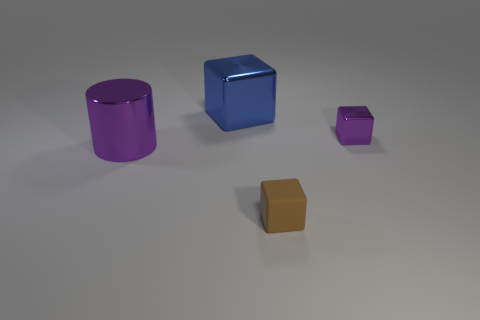Is there any other thing that has the same material as the tiny brown thing?
Your answer should be compact. No. Is the number of purple cylinders that are right of the cylinder the same as the number of blue blocks to the right of the rubber cube?
Provide a short and direct response. Yes. Is there a purple rubber cylinder?
Make the answer very short. No. What size is the matte object that is the same shape as the large blue shiny thing?
Provide a short and direct response. Small. There is a purple metal thing to the right of the brown rubber block; what size is it?
Ensure brevity in your answer.  Small. Are there more shiny things that are right of the large block than large red shiny blocks?
Your answer should be very brief. Yes. The large purple thing is what shape?
Make the answer very short. Cylinder. Does the metallic object to the left of the blue thing have the same color as the metal cube to the right of the rubber thing?
Give a very brief answer. Yes. Does the tiny shiny object have the same shape as the big purple metallic object?
Ensure brevity in your answer.  No. Is there any other thing that is the same shape as the big purple object?
Give a very brief answer. No. 